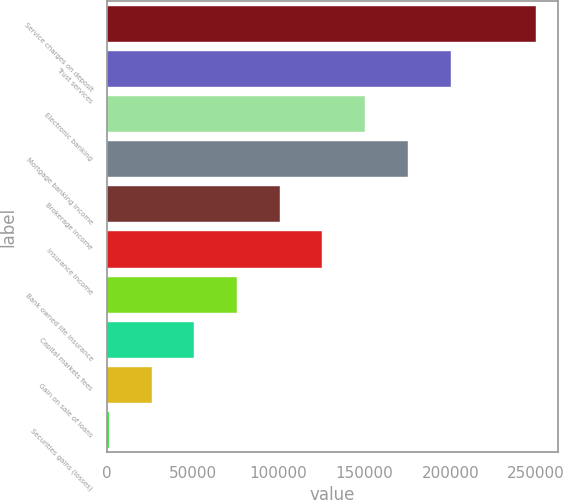Convert chart to OTSL. <chart><loc_0><loc_0><loc_500><loc_500><bar_chart><fcel>Service charges on deposit<fcel>Trust services<fcel>Electronic banking<fcel>Mortgage banking income<fcel>Brokerage income<fcel>Insurance income<fcel>Bank owned life insurance<fcel>Capital markets fees<fcel>Gain on sale of loans<fcel>Securities gains (losses)<nl><fcel>249892<fcel>200161<fcel>150431<fcel>175296<fcel>100700<fcel>125566<fcel>75834.9<fcel>50969.6<fcel>26104.3<fcel>1239<nl></chart> 